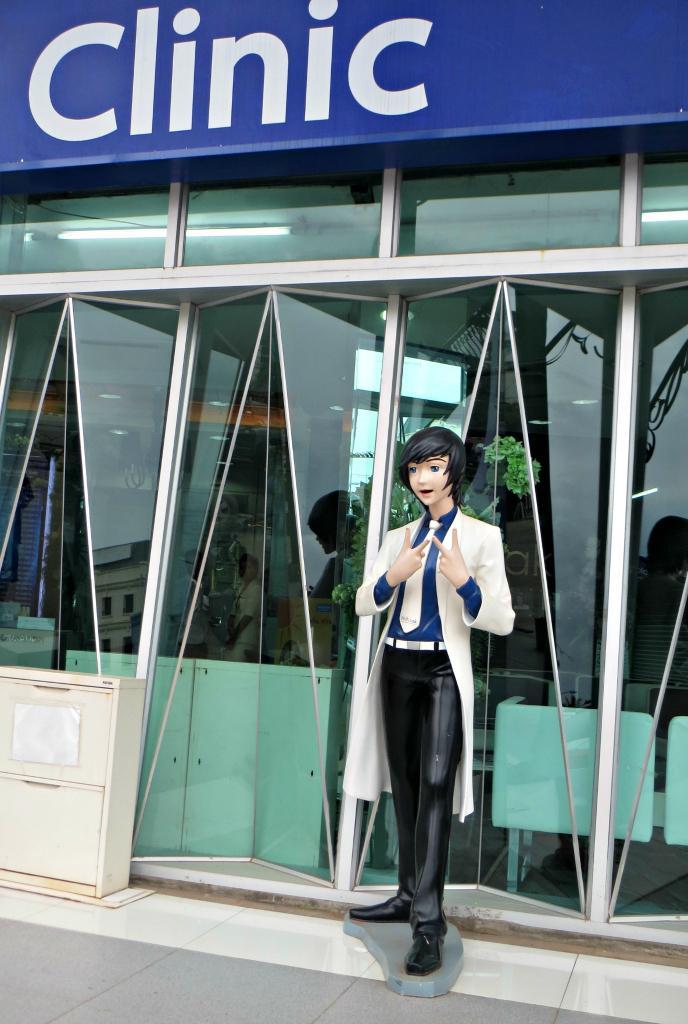In one or two sentences, can you explain what this image depicts? In this image we can see the statue on the floor and at the side, we can see the box and there is the board with text and windows. Through the window we can see the lights and chairs. 